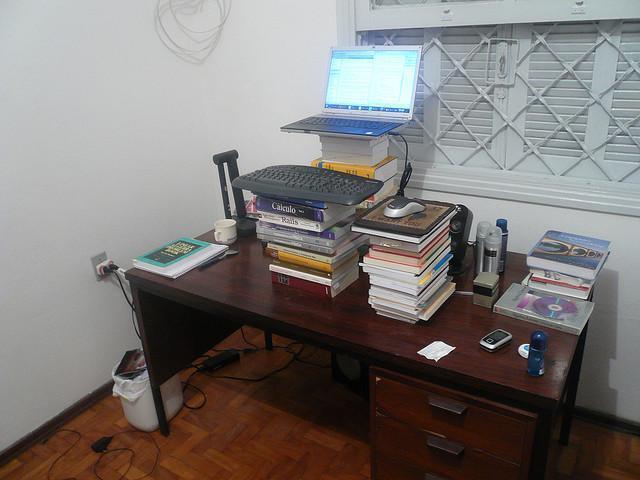How many books can be seen?
Give a very brief answer. 2. 